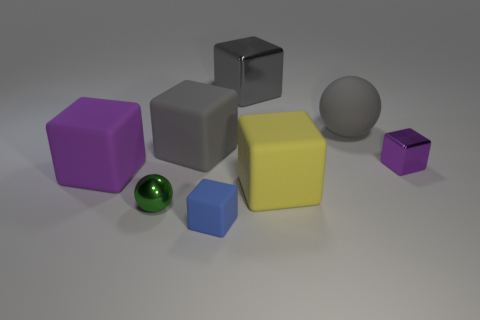Add 1 small green metallic things. How many objects exist? 9 Subtract all big gray rubber blocks. How many blocks are left? 5 Subtract all gray cubes. How many cubes are left? 4 Subtract 0 purple balls. How many objects are left? 8 Subtract all balls. How many objects are left? 6 Subtract 2 balls. How many balls are left? 0 Subtract all red cubes. Subtract all green spheres. How many cubes are left? 6 Subtract all brown cylinders. How many gray cubes are left? 2 Subtract all large gray spheres. Subtract all small purple blocks. How many objects are left? 6 Add 1 large gray cubes. How many large gray cubes are left? 3 